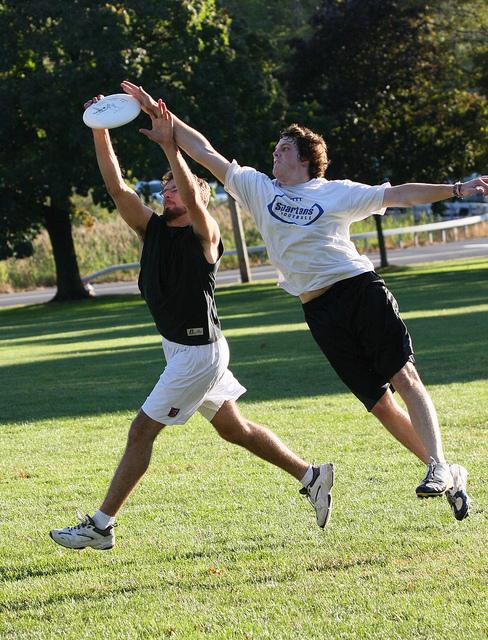The player wearing what color of shirt is likely to catch the frisbee? black 